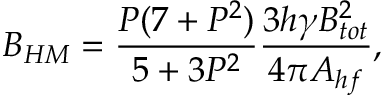Convert formula to latex. <formula><loc_0><loc_0><loc_500><loc_500>B _ { H M } = \frac { P ( 7 + P ^ { 2 } ) } { 5 + 3 P ^ { 2 } } \frac { 3 h \gamma B _ { t o t } ^ { 2 } } { 4 \pi A _ { h f } } ,</formula> 